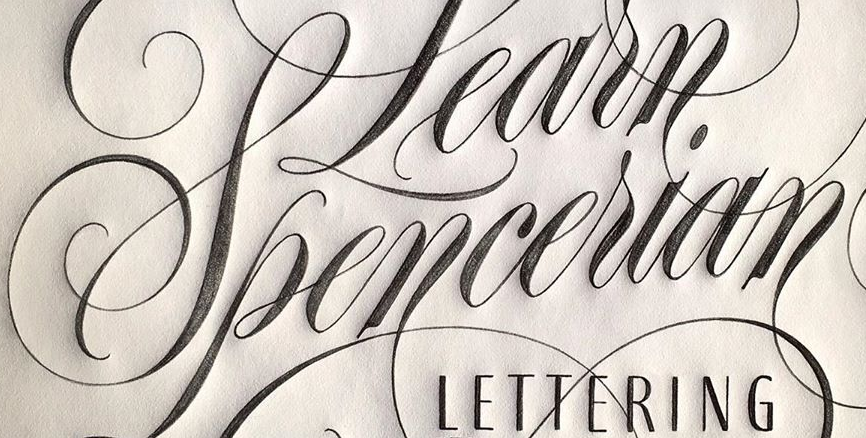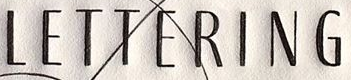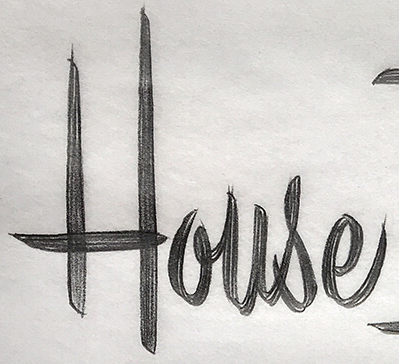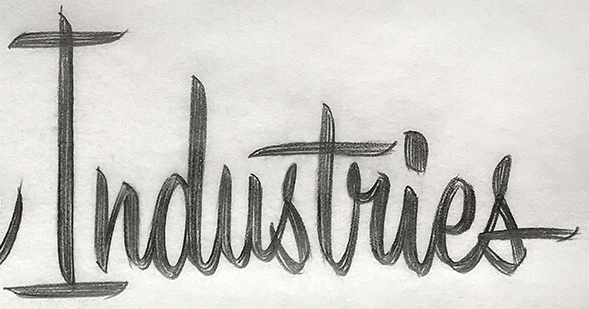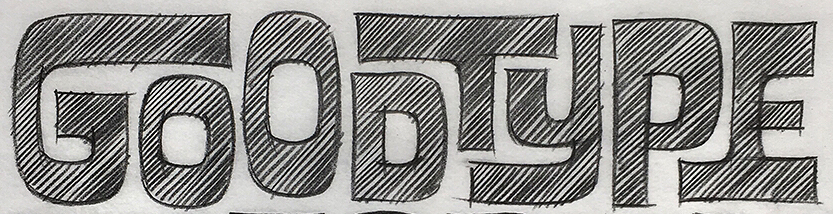Identify the words shown in these images in order, separated by a semicolon. Spencerian; LETTERING; House; Industries; GOODTYPE 